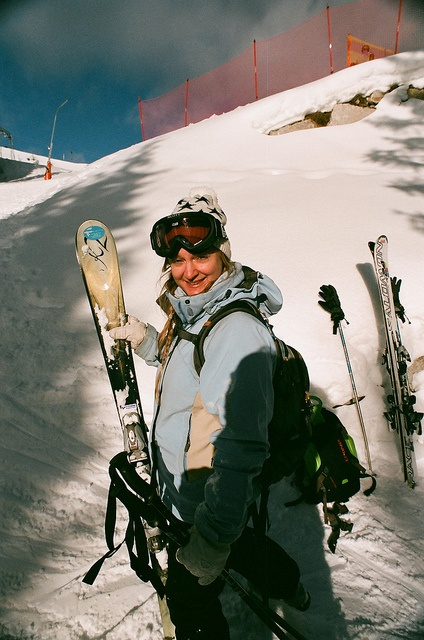Describe the objects in this image and their specific colors. I can see people in black, darkgray, tan, and gray tones, skis in black, tan, and lightgray tones, backpack in black, darkgray, gray, and darkgreen tones, and skis in black, gray, darkgray, and lightgray tones in this image. 